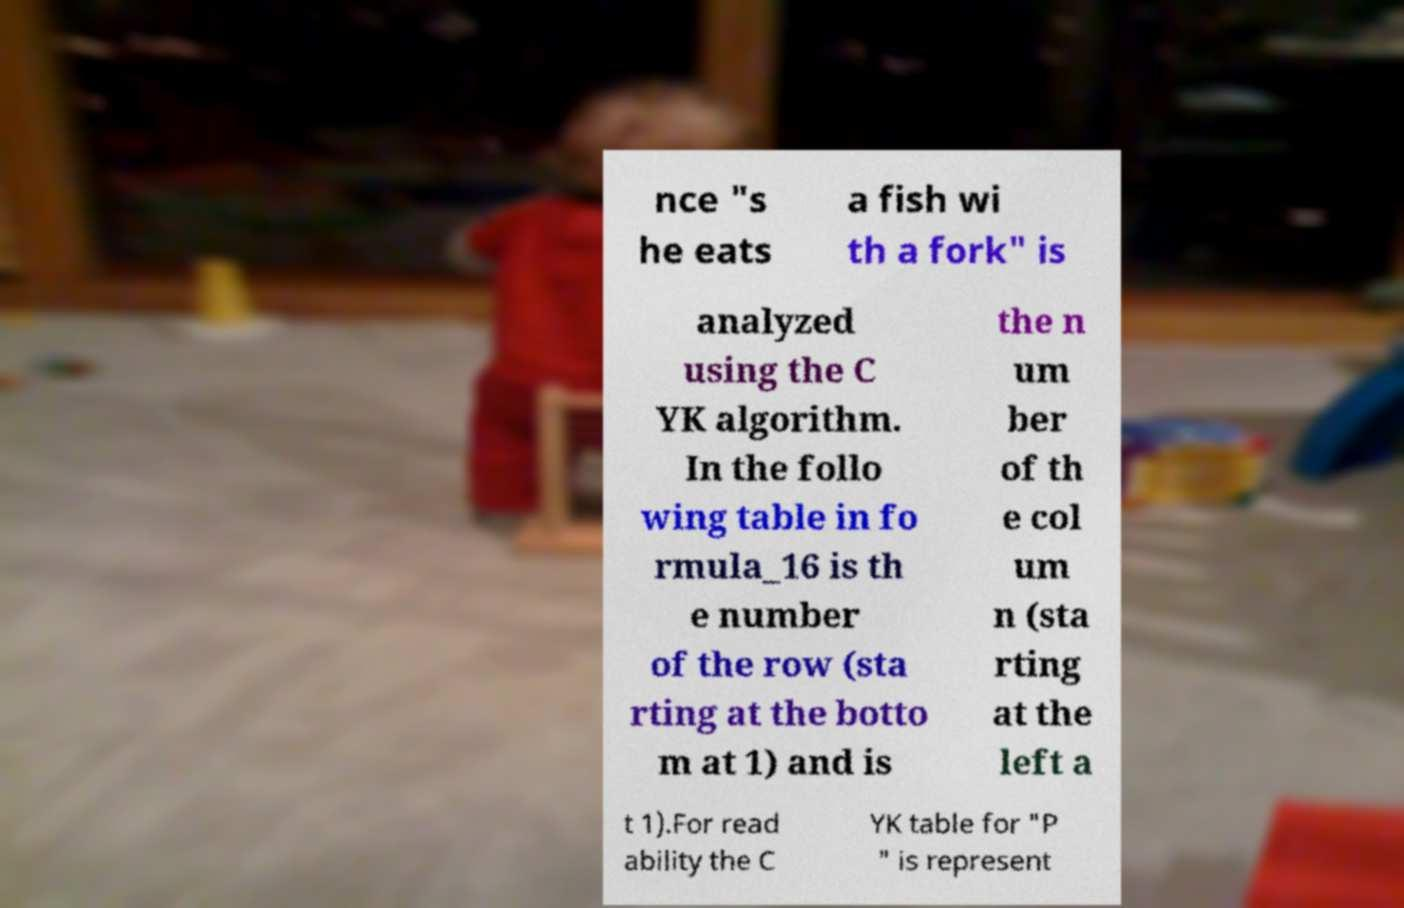What messages or text are displayed in this image? I need them in a readable, typed format. nce "s he eats a fish wi th a fork" is analyzed using the C YK algorithm. In the follo wing table in fo rmula_16 is th e number of the row (sta rting at the botto m at 1) and is the n um ber of th e col um n (sta rting at the left a t 1).For read ability the C YK table for "P " is represent 